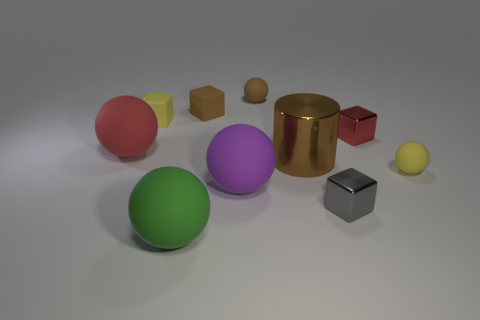Subtract all big green balls. How many balls are left? 4 Subtract all cylinders. How many objects are left? 9 Add 1 red balls. How many red balls exist? 2 Subtract all brown cubes. How many cubes are left? 3 Subtract 0 cyan spheres. How many objects are left? 10 Subtract 1 cylinders. How many cylinders are left? 0 Subtract all green blocks. Subtract all gray balls. How many blocks are left? 4 Subtract all red balls. How many purple cubes are left? 0 Subtract all gray shiny objects. Subtract all metallic blocks. How many objects are left? 7 Add 4 brown balls. How many brown balls are left? 5 